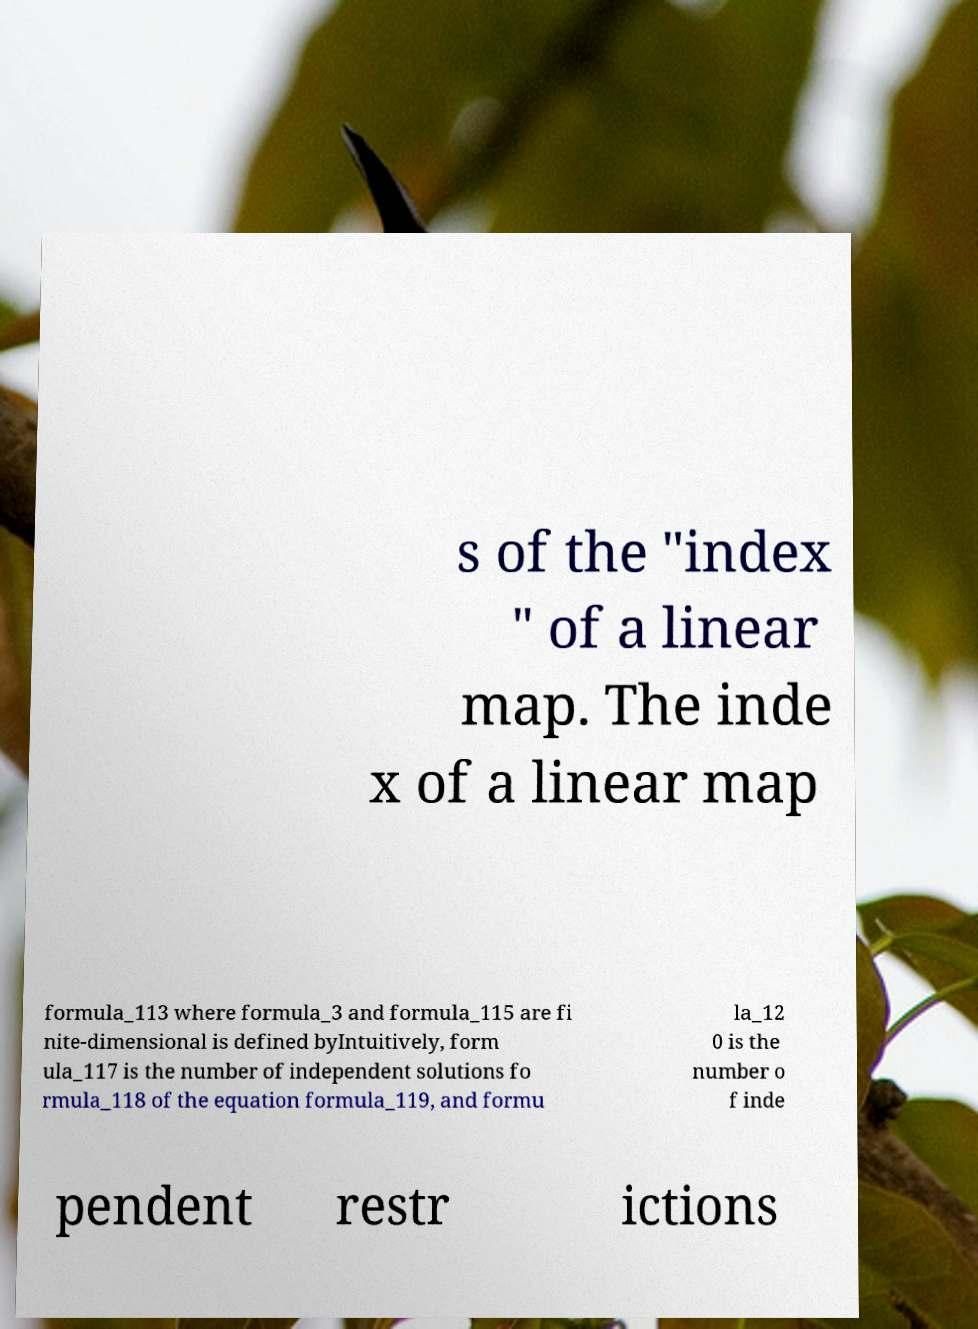Please read and relay the text visible in this image. What does it say? s of the "index " of a linear map. The inde x of a linear map formula_113 where formula_3 and formula_115 are fi nite-dimensional is defined byIntuitively, form ula_117 is the number of independent solutions fo rmula_118 of the equation formula_119, and formu la_12 0 is the number o f inde pendent restr ictions 